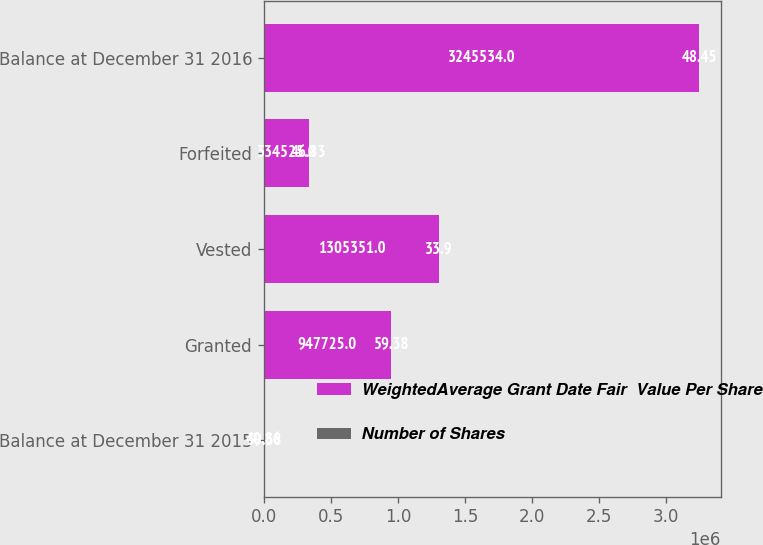Convert chart to OTSL. <chart><loc_0><loc_0><loc_500><loc_500><stacked_bar_chart><ecel><fcel>Balance at December 31 2015<fcel>Granted<fcel>Vested<fcel>Forfeited<fcel>Balance at December 31 2016<nl><fcel>WeightedAverage Grant Date Fair  Value Per Share<fcel>59.38<fcel>947725<fcel>1.30535e+06<fcel>334525<fcel>3.24553e+06<nl><fcel>Number of Shares<fcel>40.86<fcel>59.38<fcel>33.9<fcel>46.83<fcel>48.45<nl></chart> 